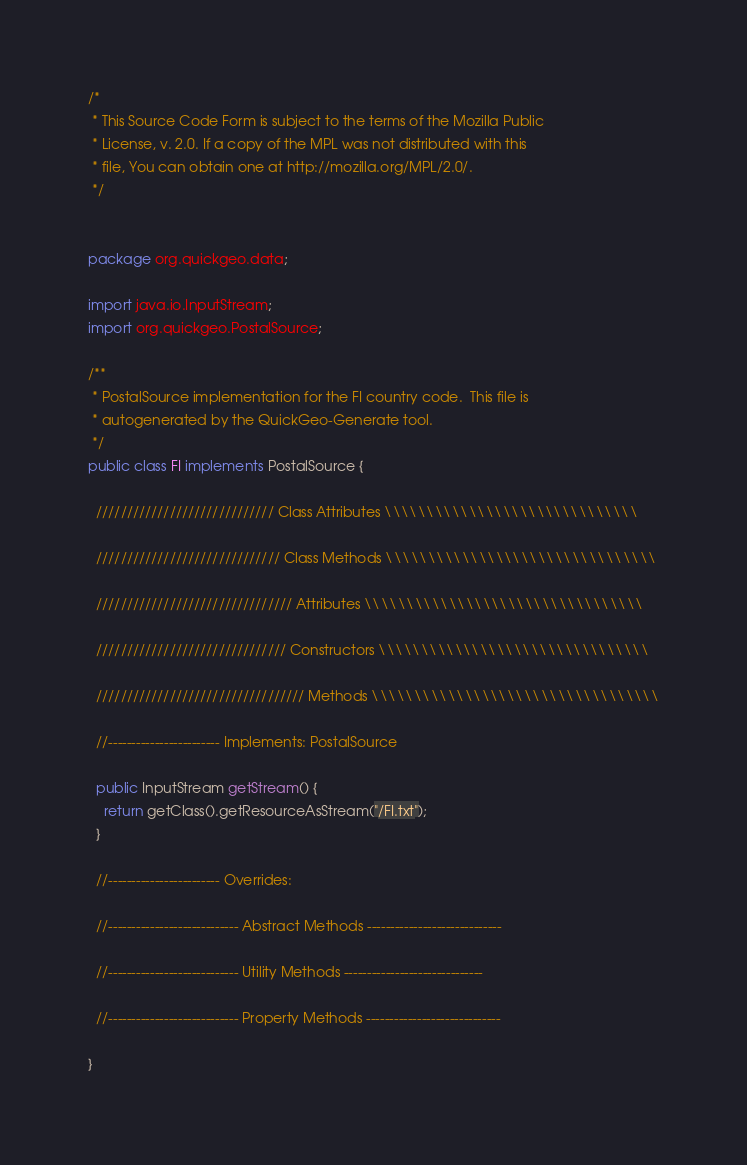<code> <loc_0><loc_0><loc_500><loc_500><_Java_>/*
 * This Source Code Form is subject to the terms of the Mozilla Public
 * License, v. 2.0. If a copy of the MPL was not distributed with this
 * file, You can obtain one at http://mozilla.org/MPL/2.0/. 
 */


package org.quickgeo.data;

import java.io.InputStream;
import org.quickgeo.PostalSource;

/**
 * PostalSource implementation for the FI country code.  This file is
 * autogenerated by the QuickGeo-Generate tool.
 */
public class FI implements PostalSource {
  
  ///////////////////////////// Class Attributes \\\\\\\\\\\\\\\\\\\\\\\\\\\\\\
  
  ////////////////////////////// Class Methods \\\\\\\\\\\\\\\\\\\\\\\\\\\\\\\\
  
  //////////////////////////////// Attributes \\\\\\\\\\\\\\\\\\\\\\\\\\\\\\\\\
  
  /////////////////////////////// Constructors \\\\\\\\\\\\\\\\\\\\\\\\\\\\\\\\  
  
  ////////////////////////////////// Methods \\\\\\\\\\\\\\\\\\\\\\\\\\\\\\\\\\
  
  //------------------------ Implements: PostalSource
  
  public InputStream getStream() {
    return getClass().getResourceAsStream("/FI.txt");
  }
  
  //------------------------ Overrides:
  
  //---------------------------- Abstract Methods -----------------------------
  
  //---------------------------- Utility Methods ------------------------------
  
  //---------------------------- Property Methods -----------------------------     

}
</code> 